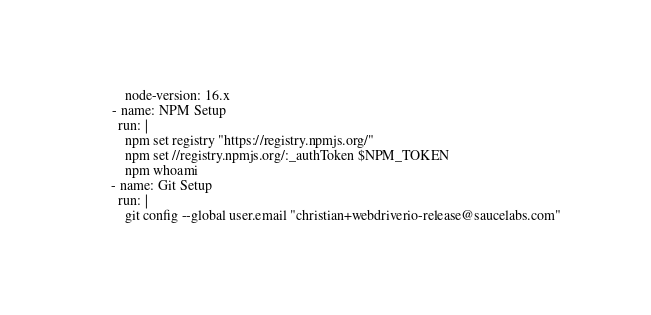Convert code to text. <code><loc_0><loc_0><loc_500><loc_500><_YAML_>          node-version: 16.x
      - name: NPM Setup
        run: |
          npm set registry "https://registry.npmjs.org/"
          npm set //registry.npmjs.org/:_authToken $NPM_TOKEN
          npm whoami
      - name: Git Setup
        run: |
          git config --global user.email "christian+webdriverio-release@saucelabs.com"</code> 